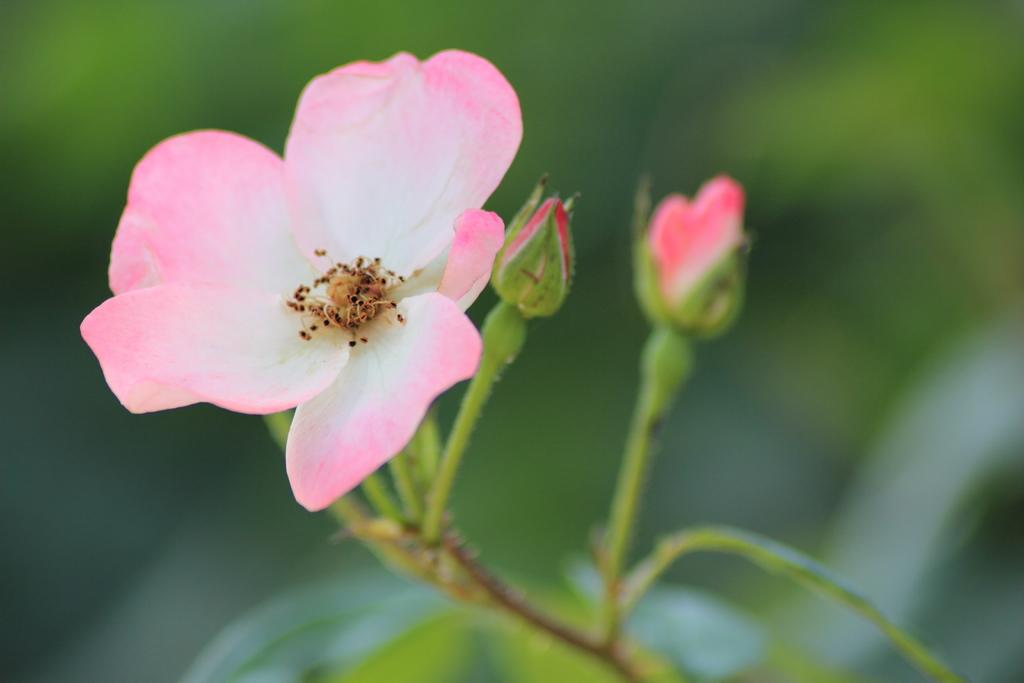What type of flower is present in the image? There is a rose flower in the image. Are there any unopened rose flowers in the image? Yes, there are rose buds in the image. What part of the rose plant can be seen in the image? There is a rose stem in the image. What is the condition of the elbow in the image? There is no elbow present in the image; it features a rose flower, rose buds, and a rose stem. 